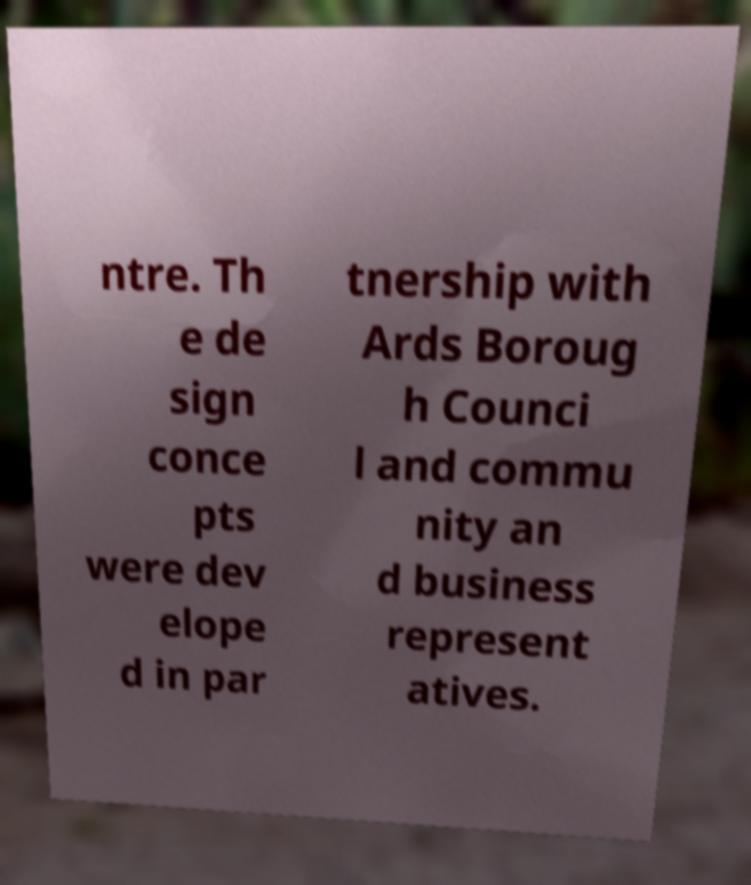What messages or text are displayed in this image? I need them in a readable, typed format. ntre. Th e de sign conce pts were dev elope d in par tnership with Ards Boroug h Counci l and commu nity an d business represent atives. 